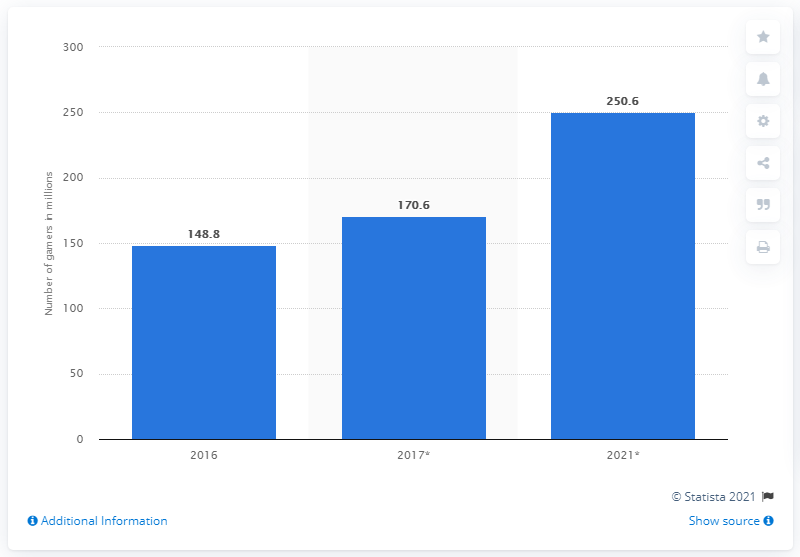List a handful of essential elements in this visual. By the end of 2021, it is expected that the number of mobile gamers will grow to 250.6 million. In 2016, there were 148.8 million mobile gamers in Southeast Asia. 